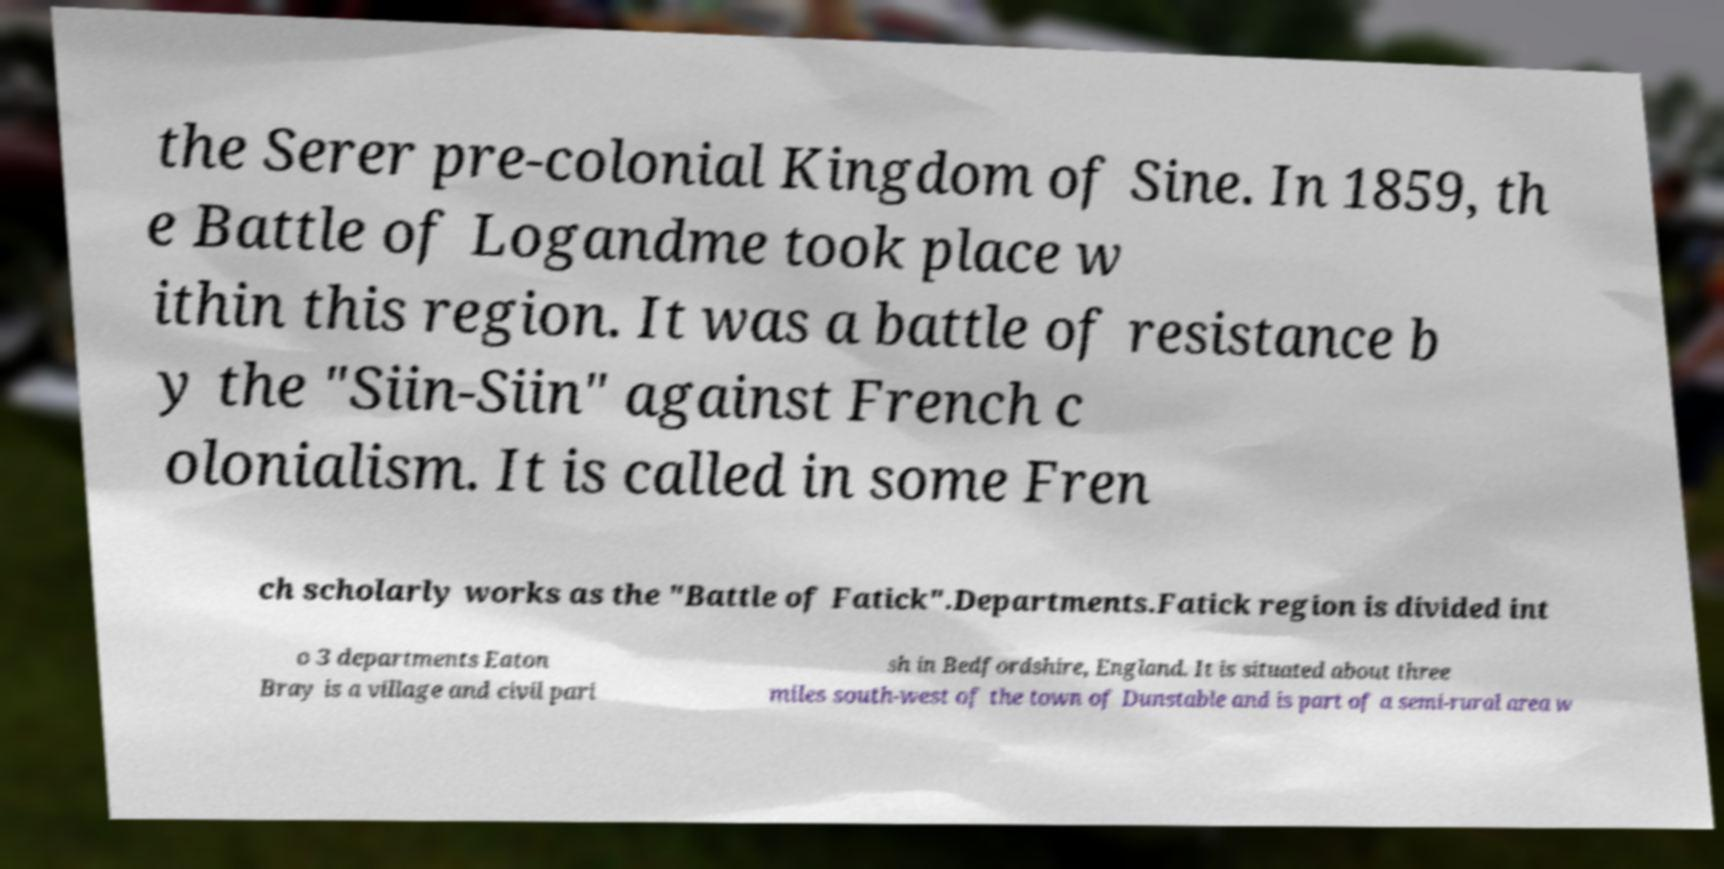What messages or text are displayed in this image? I need them in a readable, typed format. the Serer pre-colonial Kingdom of Sine. In 1859, th e Battle of Logandme took place w ithin this region. It was a battle of resistance b y the "Siin-Siin" against French c olonialism. It is called in some Fren ch scholarly works as the "Battle of Fatick".Departments.Fatick region is divided int o 3 departments Eaton Bray is a village and civil pari sh in Bedfordshire, England. It is situated about three miles south-west of the town of Dunstable and is part of a semi-rural area w 